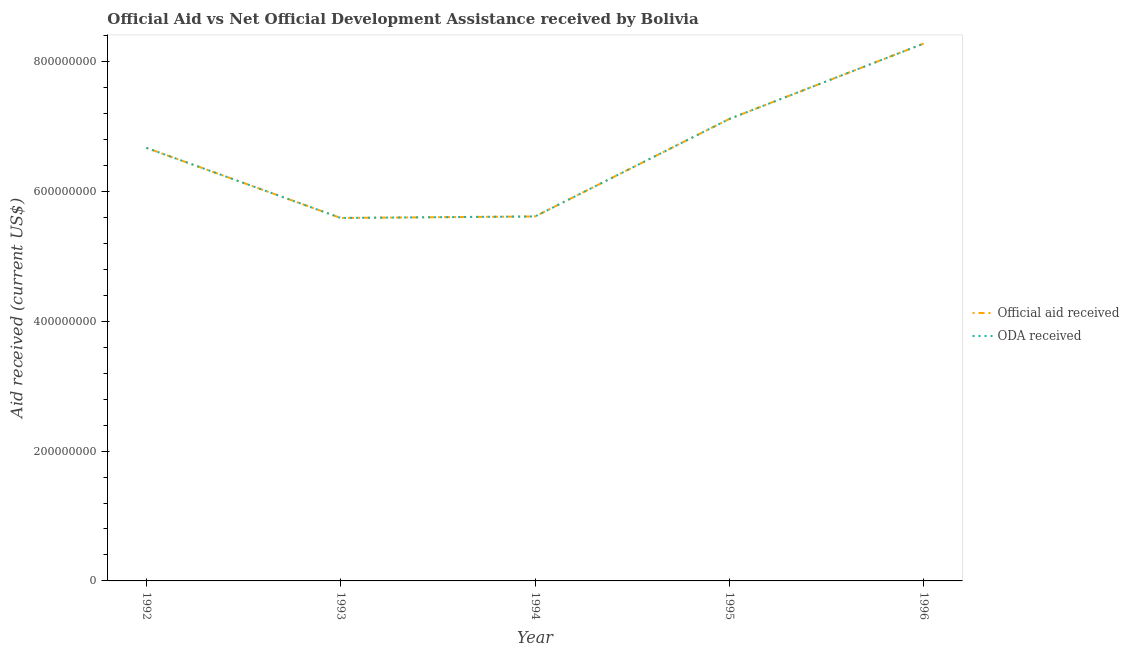How many different coloured lines are there?
Make the answer very short. 2. Does the line corresponding to oda received intersect with the line corresponding to official aid received?
Your answer should be compact. Yes. Is the number of lines equal to the number of legend labels?
Ensure brevity in your answer.  Yes. What is the official aid received in 1993?
Give a very brief answer. 5.59e+08. Across all years, what is the maximum official aid received?
Your answer should be compact. 8.28e+08. Across all years, what is the minimum official aid received?
Your answer should be compact. 5.59e+08. What is the total official aid received in the graph?
Your response must be concise. 3.33e+09. What is the difference between the official aid received in 1992 and that in 1996?
Your answer should be compact. -1.61e+08. What is the difference between the oda received in 1994 and the official aid received in 1996?
Make the answer very short. -2.66e+08. What is the average oda received per year?
Give a very brief answer. 6.65e+08. What is the ratio of the oda received in 1992 to that in 1996?
Your answer should be compact. 0.81. Is the difference between the oda received in 1992 and 1996 greater than the difference between the official aid received in 1992 and 1996?
Ensure brevity in your answer.  No. What is the difference between the highest and the second highest oda received?
Your answer should be compact. 1.16e+08. What is the difference between the highest and the lowest oda received?
Provide a succinct answer. 2.69e+08. In how many years, is the official aid received greater than the average official aid received taken over all years?
Your response must be concise. 3. Is the sum of the official aid received in 1995 and 1996 greater than the maximum oda received across all years?
Offer a terse response. Yes. Does the official aid received monotonically increase over the years?
Your response must be concise. No. Is the oda received strictly greater than the official aid received over the years?
Your response must be concise. No. Is the oda received strictly less than the official aid received over the years?
Ensure brevity in your answer.  No. What is the difference between two consecutive major ticks on the Y-axis?
Offer a terse response. 2.00e+08. Does the graph contain any zero values?
Your answer should be very brief. No. Does the graph contain grids?
Provide a short and direct response. No. How many legend labels are there?
Keep it short and to the point. 2. What is the title of the graph?
Give a very brief answer. Official Aid vs Net Official Development Assistance received by Bolivia . Does "All education staff compensation" appear as one of the legend labels in the graph?
Your response must be concise. No. What is the label or title of the X-axis?
Give a very brief answer. Year. What is the label or title of the Y-axis?
Your answer should be compact. Aid received (current US$). What is the Aid received (current US$) in Official aid received in 1992?
Your answer should be compact. 6.67e+08. What is the Aid received (current US$) of ODA received in 1992?
Give a very brief answer. 6.67e+08. What is the Aid received (current US$) of Official aid received in 1993?
Make the answer very short. 5.59e+08. What is the Aid received (current US$) in ODA received in 1993?
Give a very brief answer. 5.59e+08. What is the Aid received (current US$) in Official aid received in 1994?
Your response must be concise. 5.61e+08. What is the Aid received (current US$) in ODA received in 1994?
Your response must be concise. 5.61e+08. What is the Aid received (current US$) of Official aid received in 1995?
Provide a short and direct response. 7.11e+08. What is the Aid received (current US$) in ODA received in 1995?
Ensure brevity in your answer.  7.11e+08. What is the Aid received (current US$) in Official aid received in 1996?
Ensure brevity in your answer.  8.28e+08. What is the Aid received (current US$) in ODA received in 1996?
Give a very brief answer. 8.28e+08. Across all years, what is the maximum Aid received (current US$) of Official aid received?
Ensure brevity in your answer.  8.28e+08. Across all years, what is the maximum Aid received (current US$) of ODA received?
Ensure brevity in your answer.  8.28e+08. Across all years, what is the minimum Aid received (current US$) in Official aid received?
Offer a terse response. 5.59e+08. Across all years, what is the minimum Aid received (current US$) in ODA received?
Your answer should be compact. 5.59e+08. What is the total Aid received (current US$) in Official aid received in the graph?
Provide a succinct answer. 3.33e+09. What is the total Aid received (current US$) of ODA received in the graph?
Your answer should be compact. 3.33e+09. What is the difference between the Aid received (current US$) in Official aid received in 1992 and that in 1993?
Offer a terse response. 1.08e+08. What is the difference between the Aid received (current US$) in ODA received in 1992 and that in 1993?
Make the answer very short. 1.08e+08. What is the difference between the Aid received (current US$) of Official aid received in 1992 and that in 1994?
Make the answer very short. 1.06e+08. What is the difference between the Aid received (current US$) in ODA received in 1992 and that in 1994?
Make the answer very short. 1.06e+08. What is the difference between the Aid received (current US$) of Official aid received in 1992 and that in 1995?
Keep it short and to the point. -4.45e+07. What is the difference between the Aid received (current US$) in ODA received in 1992 and that in 1995?
Keep it short and to the point. -4.45e+07. What is the difference between the Aid received (current US$) of Official aid received in 1992 and that in 1996?
Provide a short and direct response. -1.61e+08. What is the difference between the Aid received (current US$) of ODA received in 1992 and that in 1996?
Your response must be concise. -1.61e+08. What is the difference between the Aid received (current US$) of Official aid received in 1993 and that in 1994?
Give a very brief answer. -2.29e+06. What is the difference between the Aid received (current US$) in ODA received in 1993 and that in 1994?
Offer a terse response. -2.29e+06. What is the difference between the Aid received (current US$) of Official aid received in 1993 and that in 1995?
Your response must be concise. -1.52e+08. What is the difference between the Aid received (current US$) of ODA received in 1993 and that in 1995?
Provide a succinct answer. -1.52e+08. What is the difference between the Aid received (current US$) of Official aid received in 1993 and that in 1996?
Provide a succinct answer. -2.69e+08. What is the difference between the Aid received (current US$) of ODA received in 1993 and that in 1996?
Your response must be concise. -2.69e+08. What is the difference between the Aid received (current US$) of Official aid received in 1994 and that in 1995?
Keep it short and to the point. -1.50e+08. What is the difference between the Aid received (current US$) in ODA received in 1994 and that in 1995?
Offer a very short reply. -1.50e+08. What is the difference between the Aid received (current US$) in Official aid received in 1994 and that in 1996?
Offer a very short reply. -2.66e+08. What is the difference between the Aid received (current US$) in ODA received in 1994 and that in 1996?
Offer a very short reply. -2.66e+08. What is the difference between the Aid received (current US$) of Official aid received in 1995 and that in 1996?
Offer a terse response. -1.16e+08. What is the difference between the Aid received (current US$) in ODA received in 1995 and that in 1996?
Your answer should be very brief. -1.16e+08. What is the difference between the Aid received (current US$) in Official aid received in 1992 and the Aid received (current US$) in ODA received in 1993?
Your response must be concise. 1.08e+08. What is the difference between the Aid received (current US$) in Official aid received in 1992 and the Aid received (current US$) in ODA received in 1994?
Offer a terse response. 1.06e+08. What is the difference between the Aid received (current US$) of Official aid received in 1992 and the Aid received (current US$) of ODA received in 1995?
Make the answer very short. -4.45e+07. What is the difference between the Aid received (current US$) in Official aid received in 1992 and the Aid received (current US$) in ODA received in 1996?
Keep it short and to the point. -1.61e+08. What is the difference between the Aid received (current US$) of Official aid received in 1993 and the Aid received (current US$) of ODA received in 1994?
Offer a terse response. -2.29e+06. What is the difference between the Aid received (current US$) in Official aid received in 1993 and the Aid received (current US$) in ODA received in 1995?
Offer a very short reply. -1.52e+08. What is the difference between the Aid received (current US$) of Official aid received in 1993 and the Aid received (current US$) of ODA received in 1996?
Your answer should be very brief. -2.69e+08. What is the difference between the Aid received (current US$) in Official aid received in 1994 and the Aid received (current US$) in ODA received in 1995?
Provide a succinct answer. -1.50e+08. What is the difference between the Aid received (current US$) in Official aid received in 1994 and the Aid received (current US$) in ODA received in 1996?
Keep it short and to the point. -2.66e+08. What is the difference between the Aid received (current US$) in Official aid received in 1995 and the Aid received (current US$) in ODA received in 1996?
Provide a short and direct response. -1.16e+08. What is the average Aid received (current US$) in Official aid received per year?
Ensure brevity in your answer.  6.65e+08. What is the average Aid received (current US$) in ODA received per year?
Keep it short and to the point. 6.65e+08. In the year 1992, what is the difference between the Aid received (current US$) of Official aid received and Aid received (current US$) of ODA received?
Make the answer very short. 0. In the year 1993, what is the difference between the Aid received (current US$) of Official aid received and Aid received (current US$) of ODA received?
Offer a very short reply. 0. In the year 1995, what is the difference between the Aid received (current US$) in Official aid received and Aid received (current US$) in ODA received?
Make the answer very short. 0. In the year 1996, what is the difference between the Aid received (current US$) in Official aid received and Aid received (current US$) in ODA received?
Provide a short and direct response. 0. What is the ratio of the Aid received (current US$) in Official aid received in 1992 to that in 1993?
Offer a terse response. 1.19. What is the ratio of the Aid received (current US$) of ODA received in 1992 to that in 1993?
Keep it short and to the point. 1.19. What is the ratio of the Aid received (current US$) of Official aid received in 1992 to that in 1994?
Ensure brevity in your answer.  1.19. What is the ratio of the Aid received (current US$) of ODA received in 1992 to that in 1994?
Your response must be concise. 1.19. What is the ratio of the Aid received (current US$) of Official aid received in 1992 to that in 1995?
Your response must be concise. 0.94. What is the ratio of the Aid received (current US$) of ODA received in 1992 to that in 1995?
Your answer should be very brief. 0.94. What is the ratio of the Aid received (current US$) in Official aid received in 1992 to that in 1996?
Give a very brief answer. 0.81. What is the ratio of the Aid received (current US$) of ODA received in 1992 to that in 1996?
Provide a succinct answer. 0.81. What is the ratio of the Aid received (current US$) of ODA received in 1993 to that in 1994?
Provide a short and direct response. 1. What is the ratio of the Aid received (current US$) of Official aid received in 1993 to that in 1995?
Ensure brevity in your answer.  0.79. What is the ratio of the Aid received (current US$) of ODA received in 1993 to that in 1995?
Give a very brief answer. 0.79. What is the ratio of the Aid received (current US$) in Official aid received in 1993 to that in 1996?
Ensure brevity in your answer.  0.68. What is the ratio of the Aid received (current US$) of ODA received in 1993 to that in 1996?
Your answer should be very brief. 0.68. What is the ratio of the Aid received (current US$) in Official aid received in 1994 to that in 1995?
Provide a succinct answer. 0.79. What is the ratio of the Aid received (current US$) of ODA received in 1994 to that in 1995?
Your answer should be compact. 0.79. What is the ratio of the Aid received (current US$) in Official aid received in 1994 to that in 1996?
Ensure brevity in your answer.  0.68. What is the ratio of the Aid received (current US$) of ODA received in 1994 to that in 1996?
Provide a succinct answer. 0.68. What is the ratio of the Aid received (current US$) of Official aid received in 1995 to that in 1996?
Ensure brevity in your answer.  0.86. What is the ratio of the Aid received (current US$) of ODA received in 1995 to that in 1996?
Ensure brevity in your answer.  0.86. What is the difference between the highest and the second highest Aid received (current US$) in Official aid received?
Ensure brevity in your answer.  1.16e+08. What is the difference between the highest and the second highest Aid received (current US$) of ODA received?
Keep it short and to the point. 1.16e+08. What is the difference between the highest and the lowest Aid received (current US$) in Official aid received?
Your answer should be compact. 2.69e+08. What is the difference between the highest and the lowest Aid received (current US$) in ODA received?
Give a very brief answer. 2.69e+08. 